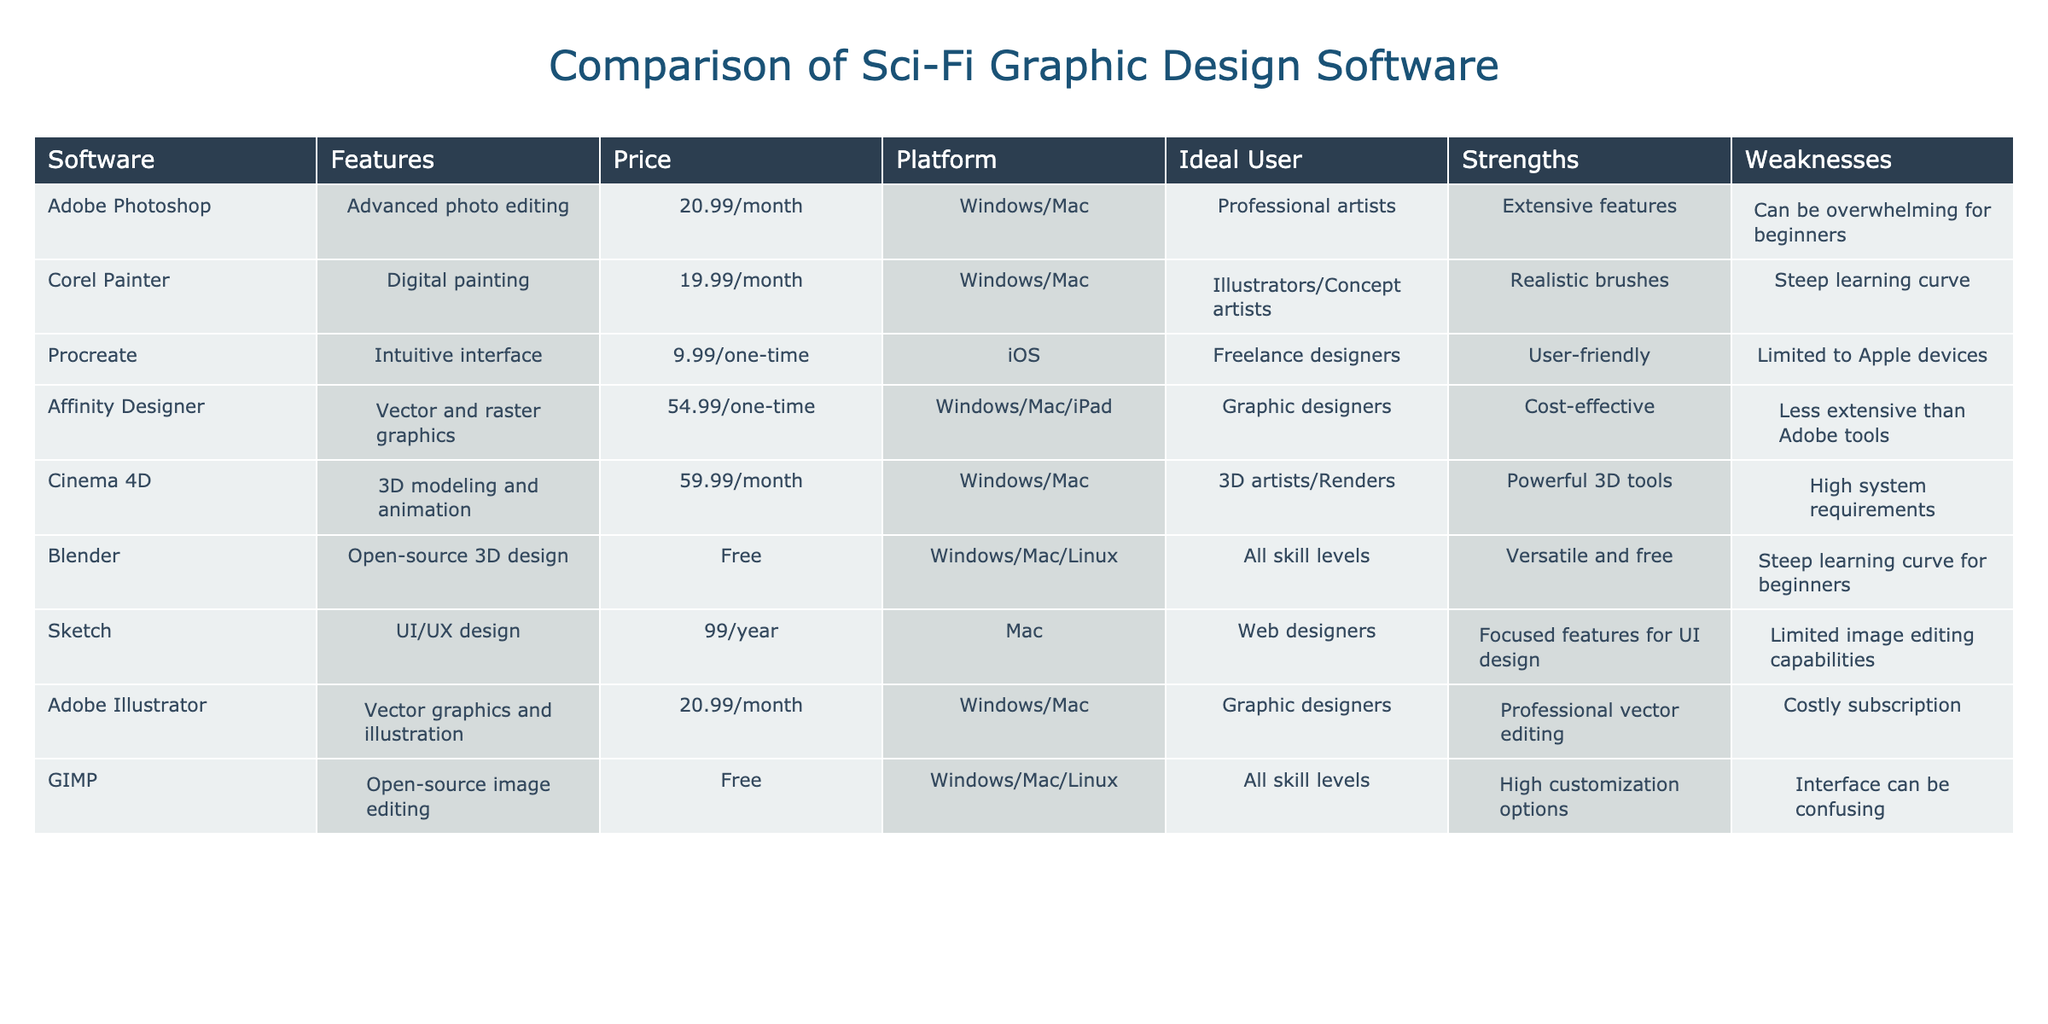What is the monthly cost of Adobe Photoshop? The table lists Adobe Photoshop's price in the "Price" column. Upon checking, it shows 20.99/month.
Answer: 20.99/month Which software has the most realistic brushes? Corel Painter is listed under the "Strengths" column, where it is stated that it offers realistic brushes. This is a specific strength noted for that software.
Answer: Corel Painter Is Affinity Designer available on iPad? In the "Platform" column, Affinity Designer is mentioned as available on Windows, Mac, and iPad. Thus, it confirms that it is indeed available for iPad users.
Answer: Yes What are the two main weaknesses of Blender? Looking into the "Weaknesses" column for Blender, it indicates a steep learning curve specifically for beginners. Since there is only one weakness listed, the question cannot have two answers. Hence, you would only mention the one weakness.
Answer: Steep learning curve for beginners What is the average price of the software tools listed? To find the average price, we first convert all costs to the same unit (monthly). The prices are: 20.99, 19.99, 9.99 (one-time), 54.99 (one-time), 59.99, free, 99/year (which is 8.25/month), 20.99, and free. Excluding free where applicable and converting one-time payments into a monthly estimate (roughly dividing by 12), the sum approximates to 39.45 with 6 contributors leading to an average of 39.45/6 = 6.575/month.
Answer: 39.45/month Does GIMP offer an interface that is confusing? From the "Weaknesses" column under GIMP, it specifically mentions that its interface can be confusing, confirming that this is true.
Answer: Yes 